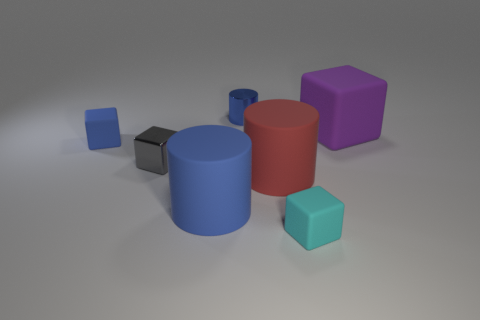How many red cylinders are the same size as the gray thing?
Make the answer very short. 0. There is a block that is made of the same material as the tiny blue cylinder; what color is it?
Keep it short and to the point. Gray. Are there fewer rubber objects that are right of the shiny cylinder than blocks?
Your answer should be very brief. Yes. What is the shape of the small blue object that is made of the same material as the small gray block?
Your response must be concise. Cylinder. How many shiny objects are either green blocks or gray objects?
Provide a short and direct response. 1. Are there an equal number of objects that are left of the blue metal object and red matte things?
Keep it short and to the point. No. Do the matte block that is on the left side of the gray metallic cube and the tiny cylinder have the same color?
Your answer should be very brief. Yes. What material is the tiny object that is both in front of the blue block and on the left side of the metallic cylinder?
Your answer should be very brief. Metal. There is a small object that is behind the big purple object; are there any big purple objects to the right of it?
Make the answer very short. Yes. Do the big purple cube and the small blue cylinder have the same material?
Provide a succinct answer. No. 